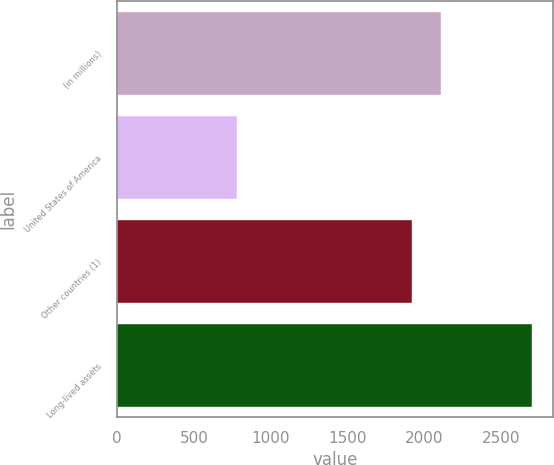Convert chart. <chart><loc_0><loc_0><loc_500><loc_500><bar_chart><fcel>(in millions)<fcel>United States of America<fcel>Other countries (1)<fcel>Long-lived assets<nl><fcel>2108.37<fcel>781.8<fcel>1916.7<fcel>2698.5<nl></chart> 